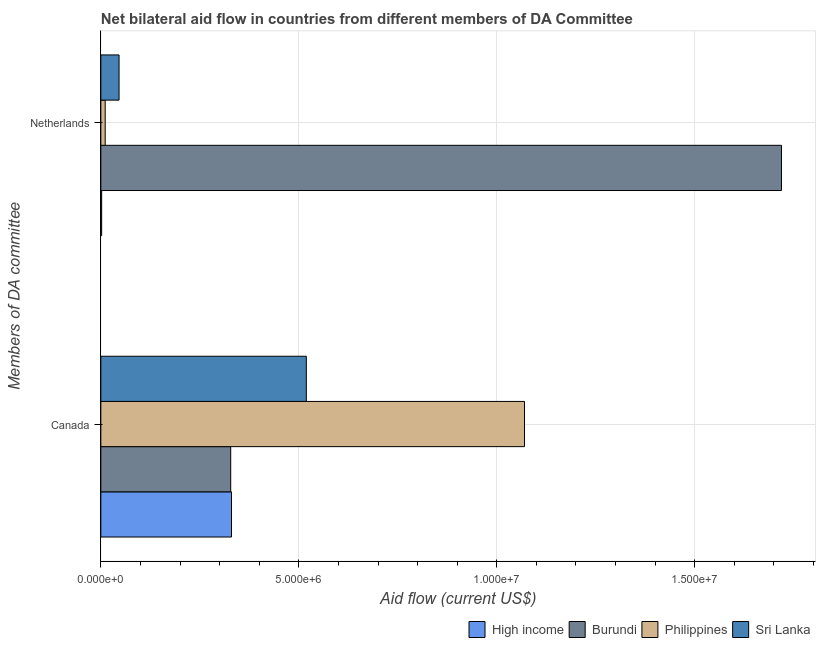Are the number of bars on each tick of the Y-axis equal?
Keep it short and to the point. Yes. How many bars are there on the 1st tick from the bottom?
Offer a very short reply. 4. What is the amount of aid given by netherlands in Sri Lanka?
Your answer should be very brief. 4.60e+05. Across all countries, what is the maximum amount of aid given by canada?
Provide a short and direct response. 1.07e+07. Across all countries, what is the minimum amount of aid given by netherlands?
Your answer should be compact. 2.00e+04. In which country was the amount of aid given by netherlands maximum?
Ensure brevity in your answer.  Burundi. In which country was the amount of aid given by canada minimum?
Give a very brief answer. Burundi. What is the total amount of aid given by canada in the graph?
Provide a succinct answer. 2.25e+07. What is the difference between the amount of aid given by canada in Burundi and that in Philippines?
Provide a short and direct response. -7.42e+06. What is the difference between the amount of aid given by canada in Burundi and the amount of aid given by netherlands in Philippines?
Your answer should be very brief. 3.17e+06. What is the average amount of aid given by netherlands per country?
Your answer should be compact. 4.44e+06. What is the difference between the amount of aid given by netherlands and amount of aid given by canada in High income?
Make the answer very short. -3.28e+06. In how many countries, is the amount of aid given by canada greater than 16000000 US$?
Your answer should be compact. 0. What is the ratio of the amount of aid given by netherlands in High income to that in Philippines?
Offer a terse response. 0.18. What does the 3rd bar from the top in Canada represents?
Offer a very short reply. Burundi. What does the 2nd bar from the bottom in Netherlands represents?
Provide a short and direct response. Burundi. How many bars are there?
Give a very brief answer. 8. How many countries are there in the graph?
Give a very brief answer. 4. Does the graph contain any zero values?
Keep it short and to the point. No. Does the graph contain grids?
Make the answer very short. Yes. How many legend labels are there?
Ensure brevity in your answer.  4. What is the title of the graph?
Give a very brief answer. Net bilateral aid flow in countries from different members of DA Committee. What is the label or title of the Y-axis?
Offer a terse response. Members of DA committee. What is the Aid flow (current US$) in High income in Canada?
Provide a short and direct response. 3.30e+06. What is the Aid flow (current US$) in Burundi in Canada?
Make the answer very short. 3.28e+06. What is the Aid flow (current US$) in Philippines in Canada?
Make the answer very short. 1.07e+07. What is the Aid flow (current US$) of Sri Lanka in Canada?
Provide a short and direct response. 5.19e+06. What is the Aid flow (current US$) of High income in Netherlands?
Keep it short and to the point. 2.00e+04. What is the Aid flow (current US$) in Burundi in Netherlands?
Keep it short and to the point. 1.72e+07. What is the Aid flow (current US$) in Philippines in Netherlands?
Your answer should be compact. 1.10e+05. Across all Members of DA committee, what is the maximum Aid flow (current US$) of High income?
Offer a very short reply. 3.30e+06. Across all Members of DA committee, what is the maximum Aid flow (current US$) of Burundi?
Your answer should be very brief. 1.72e+07. Across all Members of DA committee, what is the maximum Aid flow (current US$) of Philippines?
Your answer should be compact. 1.07e+07. Across all Members of DA committee, what is the maximum Aid flow (current US$) of Sri Lanka?
Your answer should be very brief. 5.19e+06. Across all Members of DA committee, what is the minimum Aid flow (current US$) in High income?
Ensure brevity in your answer.  2.00e+04. Across all Members of DA committee, what is the minimum Aid flow (current US$) in Burundi?
Offer a very short reply. 3.28e+06. Across all Members of DA committee, what is the minimum Aid flow (current US$) in Philippines?
Ensure brevity in your answer.  1.10e+05. What is the total Aid flow (current US$) of High income in the graph?
Ensure brevity in your answer.  3.32e+06. What is the total Aid flow (current US$) of Burundi in the graph?
Make the answer very short. 2.05e+07. What is the total Aid flow (current US$) in Philippines in the graph?
Provide a succinct answer. 1.08e+07. What is the total Aid flow (current US$) in Sri Lanka in the graph?
Keep it short and to the point. 5.65e+06. What is the difference between the Aid flow (current US$) in High income in Canada and that in Netherlands?
Provide a succinct answer. 3.28e+06. What is the difference between the Aid flow (current US$) in Burundi in Canada and that in Netherlands?
Offer a terse response. -1.39e+07. What is the difference between the Aid flow (current US$) of Philippines in Canada and that in Netherlands?
Keep it short and to the point. 1.06e+07. What is the difference between the Aid flow (current US$) of Sri Lanka in Canada and that in Netherlands?
Offer a very short reply. 4.73e+06. What is the difference between the Aid flow (current US$) in High income in Canada and the Aid flow (current US$) in Burundi in Netherlands?
Provide a short and direct response. -1.39e+07. What is the difference between the Aid flow (current US$) in High income in Canada and the Aid flow (current US$) in Philippines in Netherlands?
Your answer should be compact. 3.19e+06. What is the difference between the Aid flow (current US$) of High income in Canada and the Aid flow (current US$) of Sri Lanka in Netherlands?
Keep it short and to the point. 2.84e+06. What is the difference between the Aid flow (current US$) of Burundi in Canada and the Aid flow (current US$) of Philippines in Netherlands?
Give a very brief answer. 3.17e+06. What is the difference between the Aid flow (current US$) in Burundi in Canada and the Aid flow (current US$) in Sri Lanka in Netherlands?
Keep it short and to the point. 2.82e+06. What is the difference between the Aid flow (current US$) of Philippines in Canada and the Aid flow (current US$) of Sri Lanka in Netherlands?
Offer a very short reply. 1.02e+07. What is the average Aid flow (current US$) of High income per Members of DA committee?
Give a very brief answer. 1.66e+06. What is the average Aid flow (current US$) of Burundi per Members of DA committee?
Ensure brevity in your answer.  1.02e+07. What is the average Aid flow (current US$) in Philippines per Members of DA committee?
Offer a very short reply. 5.40e+06. What is the average Aid flow (current US$) in Sri Lanka per Members of DA committee?
Your response must be concise. 2.82e+06. What is the difference between the Aid flow (current US$) in High income and Aid flow (current US$) in Burundi in Canada?
Offer a very short reply. 2.00e+04. What is the difference between the Aid flow (current US$) of High income and Aid flow (current US$) of Philippines in Canada?
Offer a terse response. -7.40e+06. What is the difference between the Aid flow (current US$) in High income and Aid flow (current US$) in Sri Lanka in Canada?
Offer a terse response. -1.89e+06. What is the difference between the Aid flow (current US$) of Burundi and Aid flow (current US$) of Philippines in Canada?
Keep it short and to the point. -7.42e+06. What is the difference between the Aid flow (current US$) in Burundi and Aid flow (current US$) in Sri Lanka in Canada?
Give a very brief answer. -1.91e+06. What is the difference between the Aid flow (current US$) of Philippines and Aid flow (current US$) of Sri Lanka in Canada?
Make the answer very short. 5.51e+06. What is the difference between the Aid flow (current US$) of High income and Aid flow (current US$) of Burundi in Netherlands?
Your answer should be very brief. -1.72e+07. What is the difference between the Aid flow (current US$) in High income and Aid flow (current US$) in Philippines in Netherlands?
Provide a succinct answer. -9.00e+04. What is the difference between the Aid flow (current US$) in High income and Aid flow (current US$) in Sri Lanka in Netherlands?
Offer a terse response. -4.40e+05. What is the difference between the Aid flow (current US$) in Burundi and Aid flow (current US$) in Philippines in Netherlands?
Give a very brief answer. 1.71e+07. What is the difference between the Aid flow (current US$) in Burundi and Aid flow (current US$) in Sri Lanka in Netherlands?
Make the answer very short. 1.67e+07. What is the difference between the Aid flow (current US$) of Philippines and Aid flow (current US$) of Sri Lanka in Netherlands?
Offer a terse response. -3.50e+05. What is the ratio of the Aid flow (current US$) in High income in Canada to that in Netherlands?
Your response must be concise. 165. What is the ratio of the Aid flow (current US$) in Burundi in Canada to that in Netherlands?
Your answer should be compact. 0.19. What is the ratio of the Aid flow (current US$) in Philippines in Canada to that in Netherlands?
Make the answer very short. 97.27. What is the ratio of the Aid flow (current US$) in Sri Lanka in Canada to that in Netherlands?
Offer a terse response. 11.28. What is the difference between the highest and the second highest Aid flow (current US$) of High income?
Provide a succinct answer. 3.28e+06. What is the difference between the highest and the second highest Aid flow (current US$) in Burundi?
Keep it short and to the point. 1.39e+07. What is the difference between the highest and the second highest Aid flow (current US$) in Philippines?
Your answer should be very brief. 1.06e+07. What is the difference between the highest and the second highest Aid flow (current US$) of Sri Lanka?
Your answer should be very brief. 4.73e+06. What is the difference between the highest and the lowest Aid flow (current US$) of High income?
Give a very brief answer. 3.28e+06. What is the difference between the highest and the lowest Aid flow (current US$) in Burundi?
Your answer should be very brief. 1.39e+07. What is the difference between the highest and the lowest Aid flow (current US$) of Philippines?
Offer a very short reply. 1.06e+07. What is the difference between the highest and the lowest Aid flow (current US$) in Sri Lanka?
Make the answer very short. 4.73e+06. 